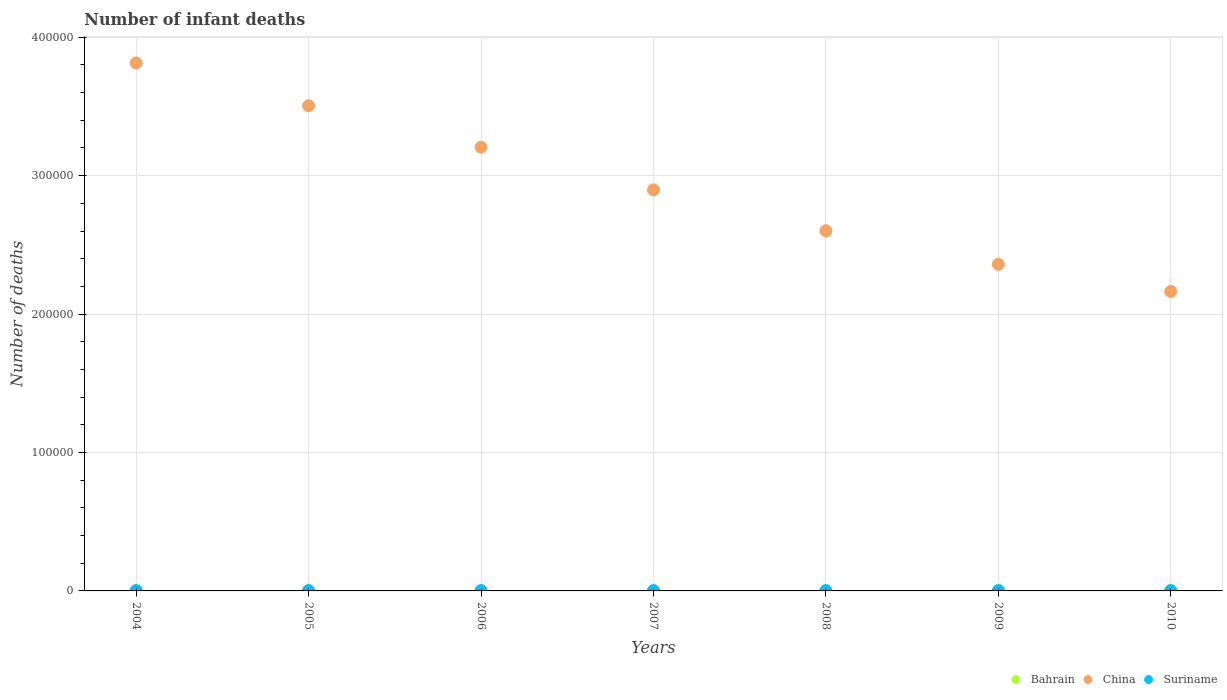Is the number of dotlines equal to the number of legend labels?
Your response must be concise. Yes. What is the number of infant deaths in Bahrain in 2010?
Give a very brief answer. 129. Across all years, what is the maximum number of infant deaths in China?
Keep it short and to the point. 3.81e+05. Across all years, what is the minimum number of infant deaths in China?
Your response must be concise. 2.16e+05. In which year was the number of infant deaths in Bahrain maximum?
Your response must be concise. 2006. What is the total number of infant deaths in China in the graph?
Ensure brevity in your answer.  2.05e+06. What is the difference between the number of infant deaths in China in 2005 and that in 2010?
Provide a short and direct response. 1.34e+05. What is the difference between the number of infant deaths in China in 2005 and the number of infant deaths in Bahrain in 2008?
Your response must be concise. 3.50e+05. What is the average number of infant deaths in China per year?
Offer a very short reply. 2.94e+05. In the year 2008, what is the difference between the number of infant deaths in Bahrain and number of infant deaths in China?
Ensure brevity in your answer.  -2.60e+05. In how many years, is the number of infant deaths in China greater than 380000?
Ensure brevity in your answer.  1. What is the ratio of the number of infant deaths in Bahrain in 2005 to that in 2007?
Keep it short and to the point. 1.01. What is the difference between the highest and the second highest number of infant deaths in Suriname?
Ensure brevity in your answer.  11. What is the difference between the highest and the lowest number of infant deaths in Bahrain?
Provide a succinct answer. 9. In how many years, is the number of infant deaths in Bahrain greater than the average number of infant deaths in Bahrain taken over all years?
Your answer should be very brief. 4. Is the sum of the number of infant deaths in China in 2005 and 2007 greater than the maximum number of infant deaths in Suriname across all years?
Ensure brevity in your answer.  Yes. Does the number of infant deaths in Suriname monotonically increase over the years?
Provide a short and direct response. No. Is the number of infant deaths in China strictly greater than the number of infant deaths in Bahrain over the years?
Give a very brief answer. Yes. How many dotlines are there?
Provide a short and direct response. 3. How many years are there in the graph?
Provide a short and direct response. 7. Are the values on the major ticks of Y-axis written in scientific E-notation?
Offer a terse response. No. Does the graph contain any zero values?
Provide a succinct answer. No. Where does the legend appear in the graph?
Your answer should be compact. Bottom right. How many legend labels are there?
Provide a short and direct response. 3. What is the title of the graph?
Offer a terse response. Number of infant deaths. Does "Vanuatu" appear as one of the legend labels in the graph?
Your response must be concise. No. What is the label or title of the X-axis?
Offer a terse response. Years. What is the label or title of the Y-axis?
Keep it short and to the point. Number of deaths. What is the Number of deaths in Bahrain in 2004?
Provide a short and direct response. 133. What is the Number of deaths of China in 2004?
Ensure brevity in your answer.  3.81e+05. What is the Number of deaths in Suriname in 2004?
Your answer should be compact. 264. What is the Number of deaths of Bahrain in 2005?
Your answer should be compact. 137. What is the Number of deaths of China in 2005?
Make the answer very short. 3.50e+05. What is the Number of deaths of Suriname in 2005?
Give a very brief answer. 253. What is the Number of deaths of Bahrain in 2006?
Provide a succinct answer. 138. What is the Number of deaths in China in 2006?
Your answer should be compact. 3.21e+05. What is the Number of deaths in Suriname in 2006?
Make the answer very short. 244. What is the Number of deaths of Bahrain in 2007?
Your answer should be compact. 136. What is the Number of deaths in China in 2007?
Your answer should be very brief. 2.90e+05. What is the Number of deaths in Suriname in 2007?
Provide a short and direct response. 238. What is the Number of deaths of Bahrain in 2008?
Make the answer very short. 136. What is the Number of deaths in China in 2008?
Your answer should be very brief. 2.60e+05. What is the Number of deaths of Suriname in 2008?
Give a very brief answer. 233. What is the Number of deaths in Bahrain in 2009?
Provide a short and direct response. 134. What is the Number of deaths in China in 2009?
Provide a short and direct response. 2.36e+05. What is the Number of deaths in Suriname in 2009?
Keep it short and to the point. 227. What is the Number of deaths in Bahrain in 2010?
Offer a very short reply. 129. What is the Number of deaths in China in 2010?
Ensure brevity in your answer.  2.16e+05. What is the Number of deaths of Suriname in 2010?
Offer a terse response. 223. Across all years, what is the maximum Number of deaths in Bahrain?
Keep it short and to the point. 138. Across all years, what is the maximum Number of deaths in China?
Your answer should be very brief. 3.81e+05. Across all years, what is the maximum Number of deaths in Suriname?
Give a very brief answer. 264. Across all years, what is the minimum Number of deaths of Bahrain?
Offer a terse response. 129. Across all years, what is the minimum Number of deaths of China?
Offer a terse response. 2.16e+05. Across all years, what is the minimum Number of deaths in Suriname?
Offer a terse response. 223. What is the total Number of deaths of Bahrain in the graph?
Make the answer very short. 943. What is the total Number of deaths in China in the graph?
Your answer should be compact. 2.05e+06. What is the total Number of deaths in Suriname in the graph?
Your response must be concise. 1682. What is the difference between the Number of deaths of Bahrain in 2004 and that in 2005?
Ensure brevity in your answer.  -4. What is the difference between the Number of deaths of China in 2004 and that in 2005?
Your answer should be very brief. 3.09e+04. What is the difference between the Number of deaths in Suriname in 2004 and that in 2005?
Keep it short and to the point. 11. What is the difference between the Number of deaths of Bahrain in 2004 and that in 2006?
Give a very brief answer. -5. What is the difference between the Number of deaths in China in 2004 and that in 2006?
Make the answer very short. 6.08e+04. What is the difference between the Number of deaths of Suriname in 2004 and that in 2006?
Offer a terse response. 20. What is the difference between the Number of deaths in Bahrain in 2004 and that in 2007?
Provide a succinct answer. -3. What is the difference between the Number of deaths in China in 2004 and that in 2007?
Your answer should be very brief. 9.17e+04. What is the difference between the Number of deaths in Bahrain in 2004 and that in 2008?
Offer a very short reply. -3. What is the difference between the Number of deaths of China in 2004 and that in 2008?
Offer a terse response. 1.21e+05. What is the difference between the Number of deaths of Bahrain in 2004 and that in 2009?
Make the answer very short. -1. What is the difference between the Number of deaths in China in 2004 and that in 2009?
Your answer should be compact. 1.45e+05. What is the difference between the Number of deaths in Bahrain in 2004 and that in 2010?
Keep it short and to the point. 4. What is the difference between the Number of deaths in China in 2004 and that in 2010?
Keep it short and to the point. 1.65e+05. What is the difference between the Number of deaths of Suriname in 2004 and that in 2010?
Keep it short and to the point. 41. What is the difference between the Number of deaths of China in 2005 and that in 2006?
Ensure brevity in your answer.  2.99e+04. What is the difference between the Number of deaths in Bahrain in 2005 and that in 2007?
Provide a succinct answer. 1. What is the difference between the Number of deaths of China in 2005 and that in 2007?
Ensure brevity in your answer.  6.08e+04. What is the difference between the Number of deaths in Bahrain in 2005 and that in 2008?
Give a very brief answer. 1. What is the difference between the Number of deaths of China in 2005 and that in 2008?
Provide a short and direct response. 9.03e+04. What is the difference between the Number of deaths in Suriname in 2005 and that in 2008?
Keep it short and to the point. 20. What is the difference between the Number of deaths in Bahrain in 2005 and that in 2009?
Keep it short and to the point. 3. What is the difference between the Number of deaths in China in 2005 and that in 2009?
Your answer should be very brief. 1.15e+05. What is the difference between the Number of deaths in China in 2005 and that in 2010?
Make the answer very short. 1.34e+05. What is the difference between the Number of deaths in Bahrain in 2006 and that in 2007?
Your response must be concise. 2. What is the difference between the Number of deaths of China in 2006 and that in 2007?
Provide a short and direct response. 3.08e+04. What is the difference between the Number of deaths of Suriname in 2006 and that in 2007?
Make the answer very short. 6. What is the difference between the Number of deaths in Bahrain in 2006 and that in 2008?
Your response must be concise. 2. What is the difference between the Number of deaths of China in 2006 and that in 2008?
Give a very brief answer. 6.04e+04. What is the difference between the Number of deaths in Suriname in 2006 and that in 2008?
Make the answer very short. 11. What is the difference between the Number of deaths of China in 2006 and that in 2009?
Provide a short and direct response. 8.46e+04. What is the difference between the Number of deaths in Bahrain in 2006 and that in 2010?
Provide a succinct answer. 9. What is the difference between the Number of deaths of China in 2006 and that in 2010?
Ensure brevity in your answer.  1.04e+05. What is the difference between the Number of deaths of China in 2007 and that in 2008?
Provide a short and direct response. 2.95e+04. What is the difference between the Number of deaths of Bahrain in 2007 and that in 2009?
Offer a very short reply. 2. What is the difference between the Number of deaths of China in 2007 and that in 2009?
Give a very brief answer. 5.38e+04. What is the difference between the Number of deaths in China in 2007 and that in 2010?
Offer a very short reply. 7.34e+04. What is the difference between the Number of deaths of Suriname in 2007 and that in 2010?
Your response must be concise. 15. What is the difference between the Number of deaths of Bahrain in 2008 and that in 2009?
Your answer should be very brief. 2. What is the difference between the Number of deaths in China in 2008 and that in 2009?
Your answer should be compact. 2.42e+04. What is the difference between the Number of deaths in China in 2008 and that in 2010?
Keep it short and to the point. 4.38e+04. What is the difference between the Number of deaths of Bahrain in 2009 and that in 2010?
Provide a succinct answer. 5. What is the difference between the Number of deaths of China in 2009 and that in 2010?
Ensure brevity in your answer.  1.96e+04. What is the difference between the Number of deaths of Suriname in 2009 and that in 2010?
Ensure brevity in your answer.  4. What is the difference between the Number of deaths in Bahrain in 2004 and the Number of deaths in China in 2005?
Make the answer very short. -3.50e+05. What is the difference between the Number of deaths in Bahrain in 2004 and the Number of deaths in Suriname in 2005?
Your answer should be compact. -120. What is the difference between the Number of deaths in China in 2004 and the Number of deaths in Suriname in 2005?
Offer a terse response. 3.81e+05. What is the difference between the Number of deaths of Bahrain in 2004 and the Number of deaths of China in 2006?
Provide a short and direct response. -3.20e+05. What is the difference between the Number of deaths in Bahrain in 2004 and the Number of deaths in Suriname in 2006?
Ensure brevity in your answer.  -111. What is the difference between the Number of deaths in China in 2004 and the Number of deaths in Suriname in 2006?
Keep it short and to the point. 3.81e+05. What is the difference between the Number of deaths in Bahrain in 2004 and the Number of deaths in China in 2007?
Provide a succinct answer. -2.90e+05. What is the difference between the Number of deaths in Bahrain in 2004 and the Number of deaths in Suriname in 2007?
Your answer should be very brief. -105. What is the difference between the Number of deaths in China in 2004 and the Number of deaths in Suriname in 2007?
Ensure brevity in your answer.  3.81e+05. What is the difference between the Number of deaths of Bahrain in 2004 and the Number of deaths of China in 2008?
Keep it short and to the point. -2.60e+05. What is the difference between the Number of deaths in Bahrain in 2004 and the Number of deaths in Suriname in 2008?
Make the answer very short. -100. What is the difference between the Number of deaths of China in 2004 and the Number of deaths of Suriname in 2008?
Make the answer very short. 3.81e+05. What is the difference between the Number of deaths of Bahrain in 2004 and the Number of deaths of China in 2009?
Your answer should be very brief. -2.36e+05. What is the difference between the Number of deaths of Bahrain in 2004 and the Number of deaths of Suriname in 2009?
Make the answer very short. -94. What is the difference between the Number of deaths in China in 2004 and the Number of deaths in Suriname in 2009?
Your response must be concise. 3.81e+05. What is the difference between the Number of deaths of Bahrain in 2004 and the Number of deaths of China in 2010?
Offer a terse response. -2.16e+05. What is the difference between the Number of deaths in Bahrain in 2004 and the Number of deaths in Suriname in 2010?
Offer a very short reply. -90. What is the difference between the Number of deaths of China in 2004 and the Number of deaths of Suriname in 2010?
Provide a succinct answer. 3.81e+05. What is the difference between the Number of deaths of Bahrain in 2005 and the Number of deaths of China in 2006?
Give a very brief answer. -3.20e+05. What is the difference between the Number of deaths of Bahrain in 2005 and the Number of deaths of Suriname in 2006?
Your answer should be very brief. -107. What is the difference between the Number of deaths in China in 2005 and the Number of deaths in Suriname in 2006?
Ensure brevity in your answer.  3.50e+05. What is the difference between the Number of deaths in Bahrain in 2005 and the Number of deaths in China in 2007?
Provide a succinct answer. -2.90e+05. What is the difference between the Number of deaths of Bahrain in 2005 and the Number of deaths of Suriname in 2007?
Your answer should be compact. -101. What is the difference between the Number of deaths in China in 2005 and the Number of deaths in Suriname in 2007?
Your response must be concise. 3.50e+05. What is the difference between the Number of deaths of Bahrain in 2005 and the Number of deaths of China in 2008?
Your answer should be compact. -2.60e+05. What is the difference between the Number of deaths of Bahrain in 2005 and the Number of deaths of Suriname in 2008?
Provide a short and direct response. -96. What is the difference between the Number of deaths in China in 2005 and the Number of deaths in Suriname in 2008?
Ensure brevity in your answer.  3.50e+05. What is the difference between the Number of deaths in Bahrain in 2005 and the Number of deaths in China in 2009?
Provide a succinct answer. -2.36e+05. What is the difference between the Number of deaths of Bahrain in 2005 and the Number of deaths of Suriname in 2009?
Provide a short and direct response. -90. What is the difference between the Number of deaths in China in 2005 and the Number of deaths in Suriname in 2009?
Provide a succinct answer. 3.50e+05. What is the difference between the Number of deaths of Bahrain in 2005 and the Number of deaths of China in 2010?
Provide a succinct answer. -2.16e+05. What is the difference between the Number of deaths of Bahrain in 2005 and the Number of deaths of Suriname in 2010?
Your answer should be very brief. -86. What is the difference between the Number of deaths in China in 2005 and the Number of deaths in Suriname in 2010?
Ensure brevity in your answer.  3.50e+05. What is the difference between the Number of deaths of Bahrain in 2006 and the Number of deaths of China in 2007?
Your response must be concise. -2.90e+05. What is the difference between the Number of deaths of Bahrain in 2006 and the Number of deaths of Suriname in 2007?
Your response must be concise. -100. What is the difference between the Number of deaths of China in 2006 and the Number of deaths of Suriname in 2007?
Offer a very short reply. 3.20e+05. What is the difference between the Number of deaths of Bahrain in 2006 and the Number of deaths of China in 2008?
Ensure brevity in your answer.  -2.60e+05. What is the difference between the Number of deaths in Bahrain in 2006 and the Number of deaths in Suriname in 2008?
Offer a very short reply. -95. What is the difference between the Number of deaths of China in 2006 and the Number of deaths of Suriname in 2008?
Offer a terse response. 3.20e+05. What is the difference between the Number of deaths in Bahrain in 2006 and the Number of deaths in China in 2009?
Your answer should be compact. -2.36e+05. What is the difference between the Number of deaths in Bahrain in 2006 and the Number of deaths in Suriname in 2009?
Provide a succinct answer. -89. What is the difference between the Number of deaths of China in 2006 and the Number of deaths of Suriname in 2009?
Keep it short and to the point. 3.20e+05. What is the difference between the Number of deaths in Bahrain in 2006 and the Number of deaths in China in 2010?
Provide a short and direct response. -2.16e+05. What is the difference between the Number of deaths in Bahrain in 2006 and the Number of deaths in Suriname in 2010?
Provide a short and direct response. -85. What is the difference between the Number of deaths in China in 2006 and the Number of deaths in Suriname in 2010?
Keep it short and to the point. 3.20e+05. What is the difference between the Number of deaths in Bahrain in 2007 and the Number of deaths in China in 2008?
Give a very brief answer. -2.60e+05. What is the difference between the Number of deaths in Bahrain in 2007 and the Number of deaths in Suriname in 2008?
Offer a very short reply. -97. What is the difference between the Number of deaths of China in 2007 and the Number of deaths of Suriname in 2008?
Keep it short and to the point. 2.90e+05. What is the difference between the Number of deaths of Bahrain in 2007 and the Number of deaths of China in 2009?
Offer a terse response. -2.36e+05. What is the difference between the Number of deaths in Bahrain in 2007 and the Number of deaths in Suriname in 2009?
Your answer should be compact. -91. What is the difference between the Number of deaths of China in 2007 and the Number of deaths of Suriname in 2009?
Provide a short and direct response. 2.90e+05. What is the difference between the Number of deaths of Bahrain in 2007 and the Number of deaths of China in 2010?
Give a very brief answer. -2.16e+05. What is the difference between the Number of deaths in Bahrain in 2007 and the Number of deaths in Suriname in 2010?
Provide a short and direct response. -87. What is the difference between the Number of deaths of China in 2007 and the Number of deaths of Suriname in 2010?
Your answer should be compact. 2.90e+05. What is the difference between the Number of deaths in Bahrain in 2008 and the Number of deaths in China in 2009?
Make the answer very short. -2.36e+05. What is the difference between the Number of deaths in Bahrain in 2008 and the Number of deaths in Suriname in 2009?
Your response must be concise. -91. What is the difference between the Number of deaths in China in 2008 and the Number of deaths in Suriname in 2009?
Ensure brevity in your answer.  2.60e+05. What is the difference between the Number of deaths in Bahrain in 2008 and the Number of deaths in China in 2010?
Ensure brevity in your answer.  -2.16e+05. What is the difference between the Number of deaths in Bahrain in 2008 and the Number of deaths in Suriname in 2010?
Offer a very short reply. -87. What is the difference between the Number of deaths of China in 2008 and the Number of deaths of Suriname in 2010?
Offer a terse response. 2.60e+05. What is the difference between the Number of deaths of Bahrain in 2009 and the Number of deaths of China in 2010?
Keep it short and to the point. -2.16e+05. What is the difference between the Number of deaths in Bahrain in 2009 and the Number of deaths in Suriname in 2010?
Give a very brief answer. -89. What is the difference between the Number of deaths of China in 2009 and the Number of deaths of Suriname in 2010?
Offer a very short reply. 2.36e+05. What is the average Number of deaths of Bahrain per year?
Your answer should be compact. 134.71. What is the average Number of deaths in China per year?
Keep it short and to the point. 2.94e+05. What is the average Number of deaths of Suriname per year?
Offer a terse response. 240.29. In the year 2004, what is the difference between the Number of deaths of Bahrain and Number of deaths of China?
Your answer should be compact. -3.81e+05. In the year 2004, what is the difference between the Number of deaths of Bahrain and Number of deaths of Suriname?
Provide a short and direct response. -131. In the year 2004, what is the difference between the Number of deaths in China and Number of deaths in Suriname?
Your response must be concise. 3.81e+05. In the year 2005, what is the difference between the Number of deaths in Bahrain and Number of deaths in China?
Offer a terse response. -3.50e+05. In the year 2005, what is the difference between the Number of deaths of Bahrain and Number of deaths of Suriname?
Ensure brevity in your answer.  -116. In the year 2005, what is the difference between the Number of deaths in China and Number of deaths in Suriname?
Offer a terse response. 3.50e+05. In the year 2006, what is the difference between the Number of deaths in Bahrain and Number of deaths in China?
Provide a succinct answer. -3.20e+05. In the year 2006, what is the difference between the Number of deaths of Bahrain and Number of deaths of Suriname?
Your response must be concise. -106. In the year 2006, what is the difference between the Number of deaths in China and Number of deaths in Suriname?
Ensure brevity in your answer.  3.20e+05. In the year 2007, what is the difference between the Number of deaths of Bahrain and Number of deaths of China?
Offer a terse response. -2.90e+05. In the year 2007, what is the difference between the Number of deaths of Bahrain and Number of deaths of Suriname?
Ensure brevity in your answer.  -102. In the year 2007, what is the difference between the Number of deaths in China and Number of deaths in Suriname?
Make the answer very short. 2.89e+05. In the year 2008, what is the difference between the Number of deaths in Bahrain and Number of deaths in China?
Your answer should be compact. -2.60e+05. In the year 2008, what is the difference between the Number of deaths of Bahrain and Number of deaths of Suriname?
Ensure brevity in your answer.  -97. In the year 2008, what is the difference between the Number of deaths in China and Number of deaths in Suriname?
Provide a short and direct response. 2.60e+05. In the year 2009, what is the difference between the Number of deaths in Bahrain and Number of deaths in China?
Offer a very short reply. -2.36e+05. In the year 2009, what is the difference between the Number of deaths in Bahrain and Number of deaths in Suriname?
Your answer should be very brief. -93. In the year 2009, what is the difference between the Number of deaths of China and Number of deaths of Suriname?
Make the answer very short. 2.36e+05. In the year 2010, what is the difference between the Number of deaths in Bahrain and Number of deaths in China?
Provide a short and direct response. -2.16e+05. In the year 2010, what is the difference between the Number of deaths of Bahrain and Number of deaths of Suriname?
Ensure brevity in your answer.  -94. In the year 2010, what is the difference between the Number of deaths of China and Number of deaths of Suriname?
Provide a short and direct response. 2.16e+05. What is the ratio of the Number of deaths of Bahrain in 2004 to that in 2005?
Your response must be concise. 0.97. What is the ratio of the Number of deaths in China in 2004 to that in 2005?
Provide a short and direct response. 1.09. What is the ratio of the Number of deaths of Suriname in 2004 to that in 2005?
Ensure brevity in your answer.  1.04. What is the ratio of the Number of deaths of Bahrain in 2004 to that in 2006?
Your response must be concise. 0.96. What is the ratio of the Number of deaths of China in 2004 to that in 2006?
Ensure brevity in your answer.  1.19. What is the ratio of the Number of deaths in Suriname in 2004 to that in 2006?
Provide a short and direct response. 1.08. What is the ratio of the Number of deaths in Bahrain in 2004 to that in 2007?
Offer a very short reply. 0.98. What is the ratio of the Number of deaths of China in 2004 to that in 2007?
Make the answer very short. 1.32. What is the ratio of the Number of deaths of Suriname in 2004 to that in 2007?
Give a very brief answer. 1.11. What is the ratio of the Number of deaths of Bahrain in 2004 to that in 2008?
Your answer should be very brief. 0.98. What is the ratio of the Number of deaths in China in 2004 to that in 2008?
Your answer should be very brief. 1.47. What is the ratio of the Number of deaths in Suriname in 2004 to that in 2008?
Ensure brevity in your answer.  1.13. What is the ratio of the Number of deaths in China in 2004 to that in 2009?
Offer a very short reply. 1.62. What is the ratio of the Number of deaths in Suriname in 2004 to that in 2009?
Your response must be concise. 1.16. What is the ratio of the Number of deaths in Bahrain in 2004 to that in 2010?
Your answer should be compact. 1.03. What is the ratio of the Number of deaths of China in 2004 to that in 2010?
Give a very brief answer. 1.76. What is the ratio of the Number of deaths in Suriname in 2004 to that in 2010?
Give a very brief answer. 1.18. What is the ratio of the Number of deaths in Bahrain in 2005 to that in 2006?
Offer a terse response. 0.99. What is the ratio of the Number of deaths in China in 2005 to that in 2006?
Your answer should be compact. 1.09. What is the ratio of the Number of deaths in Suriname in 2005 to that in 2006?
Offer a terse response. 1.04. What is the ratio of the Number of deaths in Bahrain in 2005 to that in 2007?
Your response must be concise. 1.01. What is the ratio of the Number of deaths in China in 2005 to that in 2007?
Your response must be concise. 1.21. What is the ratio of the Number of deaths of Suriname in 2005 to that in 2007?
Make the answer very short. 1.06. What is the ratio of the Number of deaths of Bahrain in 2005 to that in 2008?
Your response must be concise. 1.01. What is the ratio of the Number of deaths in China in 2005 to that in 2008?
Make the answer very short. 1.35. What is the ratio of the Number of deaths of Suriname in 2005 to that in 2008?
Provide a succinct answer. 1.09. What is the ratio of the Number of deaths of Bahrain in 2005 to that in 2009?
Your answer should be very brief. 1.02. What is the ratio of the Number of deaths in China in 2005 to that in 2009?
Offer a very short reply. 1.49. What is the ratio of the Number of deaths in Suriname in 2005 to that in 2009?
Ensure brevity in your answer.  1.11. What is the ratio of the Number of deaths in Bahrain in 2005 to that in 2010?
Provide a succinct answer. 1.06. What is the ratio of the Number of deaths of China in 2005 to that in 2010?
Your answer should be compact. 1.62. What is the ratio of the Number of deaths in Suriname in 2005 to that in 2010?
Make the answer very short. 1.13. What is the ratio of the Number of deaths of Bahrain in 2006 to that in 2007?
Ensure brevity in your answer.  1.01. What is the ratio of the Number of deaths of China in 2006 to that in 2007?
Ensure brevity in your answer.  1.11. What is the ratio of the Number of deaths of Suriname in 2006 to that in 2007?
Keep it short and to the point. 1.03. What is the ratio of the Number of deaths in Bahrain in 2006 to that in 2008?
Your answer should be compact. 1.01. What is the ratio of the Number of deaths of China in 2006 to that in 2008?
Give a very brief answer. 1.23. What is the ratio of the Number of deaths in Suriname in 2006 to that in 2008?
Keep it short and to the point. 1.05. What is the ratio of the Number of deaths of Bahrain in 2006 to that in 2009?
Your answer should be very brief. 1.03. What is the ratio of the Number of deaths of China in 2006 to that in 2009?
Offer a very short reply. 1.36. What is the ratio of the Number of deaths in Suriname in 2006 to that in 2009?
Provide a succinct answer. 1.07. What is the ratio of the Number of deaths of Bahrain in 2006 to that in 2010?
Ensure brevity in your answer.  1.07. What is the ratio of the Number of deaths of China in 2006 to that in 2010?
Make the answer very short. 1.48. What is the ratio of the Number of deaths in Suriname in 2006 to that in 2010?
Your answer should be very brief. 1.09. What is the ratio of the Number of deaths in China in 2007 to that in 2008?
Your response must be concise. 1.11. What is the ratio of the Number of deaths of Suriname in 2007 to that in 2008?
Provide a short and direct response. 1.02. What is the ratio of the Number of deaths in Bahrain in 2007 to that in 2009?
Ensure brevity in your answer.  1.01. What is the ratio of the Number of deaths of China in 2007 to that in 2009?
Give a very brief answer. 1.23. What is the ratio of the Number of deaths of Suriname in 2007 to that in 2009?
Your answer should be compact. 1.05. What is the ratio of the Number of deaths of Bahrain in 2007 to that in 2010?
Ensure brevity in your answer.  1.05. What is the ratio of the Number of deaths in China in 2007 to that in 2010?
Give a very brief answer. 1.34. What is the ratio of the Number of deaths of Suriname in 2007 to that in 2010?
Your response must be concise. 1.07. What is the ratio of the Number of deaths of Bahrain in 2008 to that in 2009?
Offer a terse response. 1.01. What is the ratio of the Number of deaths in China in 2008 to that in 2009?
Make the answer very short. 1.1. What is the ratio of the Number of deaths of Suriname in 2008 to that in 2009?
Provide a succinct answer. 1.03. What is the ratio of the Number of deaths of Bahrain in 2008 to that in 2010?
Ensure brevity in your answer.  1.05. What is the ratio of the Number of deaths of China in 2008 to that in 2010?
Make the answer very short. 1.2. What is the ratio of the Number of deaths in Suriname in 2008 to that in 2010?
Offer a terse response. 1.04. What is the ratio of the Number of deaths in Bahrain in 2009 to that in 2010?
Your answer should be very brief. 1.04. What is the ratio of the Number of deaths in China in 2009 to that in 2010?
Offer a very short reply. 1.09. What is the ratio of the Number of deaths of Suriname in 2009 to that in 2010?
Keep it short and to the point. 1.02. What is the difference between the highest and the second highest Number of deaths in Bahrain?
Provide a short and direct response. 1. What is the difference between the highest and the second highest Number of deaths in China?
Offer a very short reply. 3.09e+04. What is the difference between the highest and the second highest Number of deaths in Suriname?
Provide a succinct answer. 11. What is the difference between the highest and the lowest Number of deaths of China?
Make the answer very short. 1.65e+05. What is the difference between the highest and the lowest Number of deaths in Suriname?
Ensure brevity in your answer.  41. 